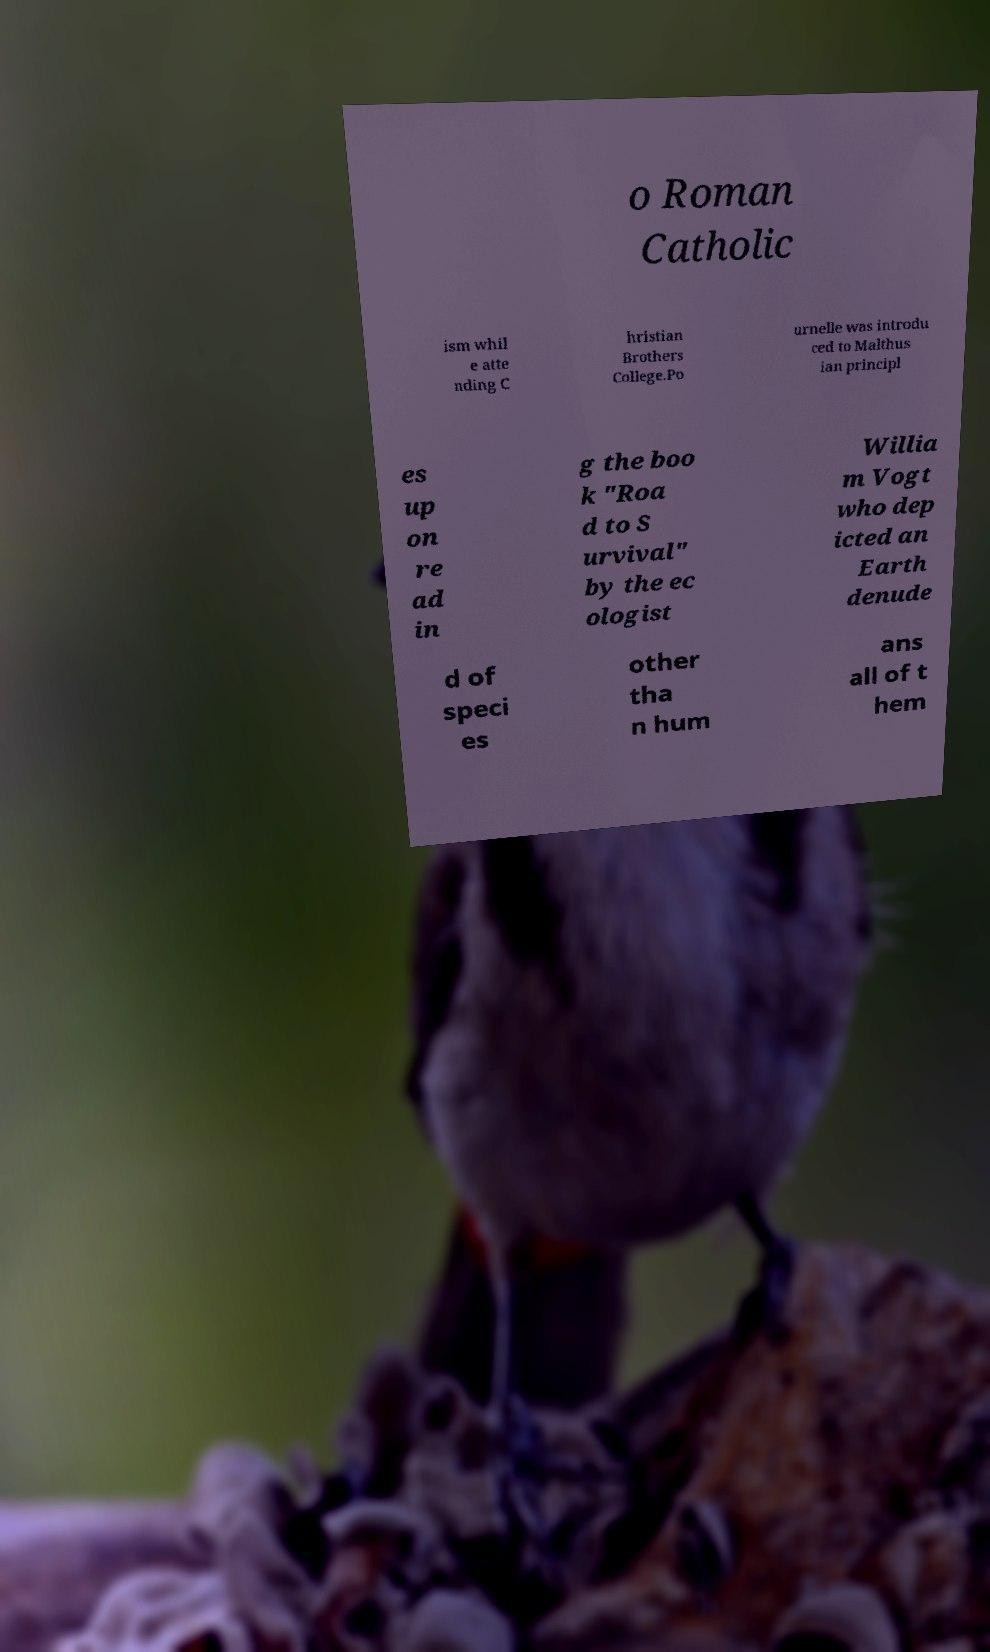There's text embedded in this image that I need extracted. Can you transcribe it verbatim? o Roman Catholic ism whil e atte nding C hristian Brothers College.Po urnelle was introdu ced to Malthus ian principl es up on re ad in g the boo k "Roa d to S urvival" by the ec ologist Willia m Vogt who dep icted an Earth denude d of speci es other tha n hum ans all of t hem 